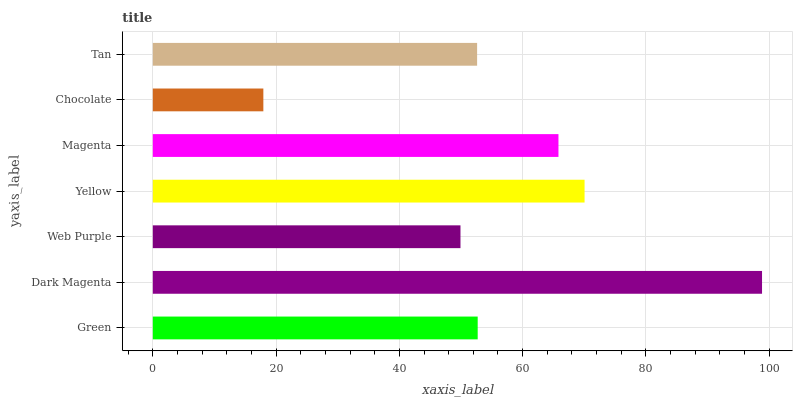Is Chocolate the minimum?
Answer yes or no. Yes. Is Dark Magenta the maximum?
Answer yes or no. Yes. Is Web Purple the minimum?
Answer yes or no. No. Is Web Purple the maximum?
Answer yes or no. No. Is Dark Magenta greater than Web Purple?
Answer yes or no. Yes. Is Web Purple less than Dark Magenta?
Answer yes or no. Yes. Is Web Purple greater than Dark Magenta?
Answer yes or no. No. Is Dark Magenta less than Web Purple?
Answer yes or no. No. Is Green the high median?
Answer yes or no. Yes. Is Green the low median?
Answer yes or no. Yes. Is Magenta the high median?
Answer yes or no. No. Is Tan the low median?
Answer yes or no. No. 